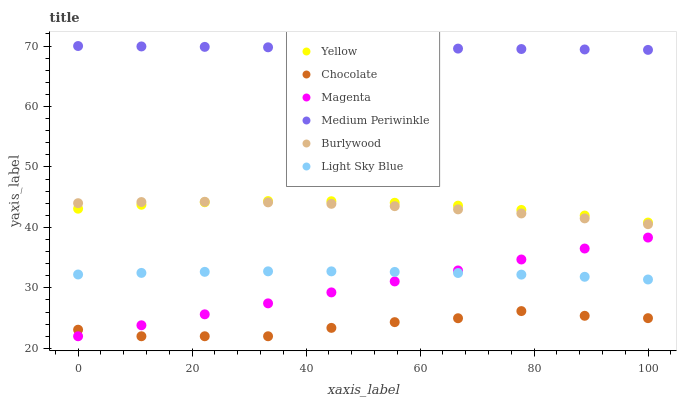Does Chocolate have the minimum area under the curve?
Answer yes or no. Yes. Does Medium Periwinkle have the maximum area under the curve?
Answer yes or no. Yes. Does Yellow have the minimum area under the curve?
Answer yes or no. No. Does Yellow have the maximum area under the curve?
Answer yes or no. No. Is Magenta the smoothest?
Answer yes or no. Yes. Is Chocolate the roughest?
Answer yes or no. Yes. Is Medium Periwinkle the smoothest?
Answer yes or no. No. Is Medium Periwinkle the roughest?
Answer yes or no. No. Does Chocolate have the lowest value?
Answer yes or no. Yes. Does Yellow have the lowest value?
Answer yes or no. No. Does Medium Periwinkle have the highest value?
Answer yes or no. Yes. Does Yellow have the highest value?
Answer yes or no. No. Is Chocolate less than Medium Periwinkle?
Answer yes or no. Yes. Is Burlywood greater than Magenta?
Answer yes or no. Yes. Does Yellow intersect Burlywood?
Answer yes or no. Yes. Is Yellow less than Burlywood?
Answer yes or no. No. Is Yellow greater than Burlywood?
Answer yes or no. No. Does Chocolate intersect Medium Periwinkle?
Answer yes or no. No. 